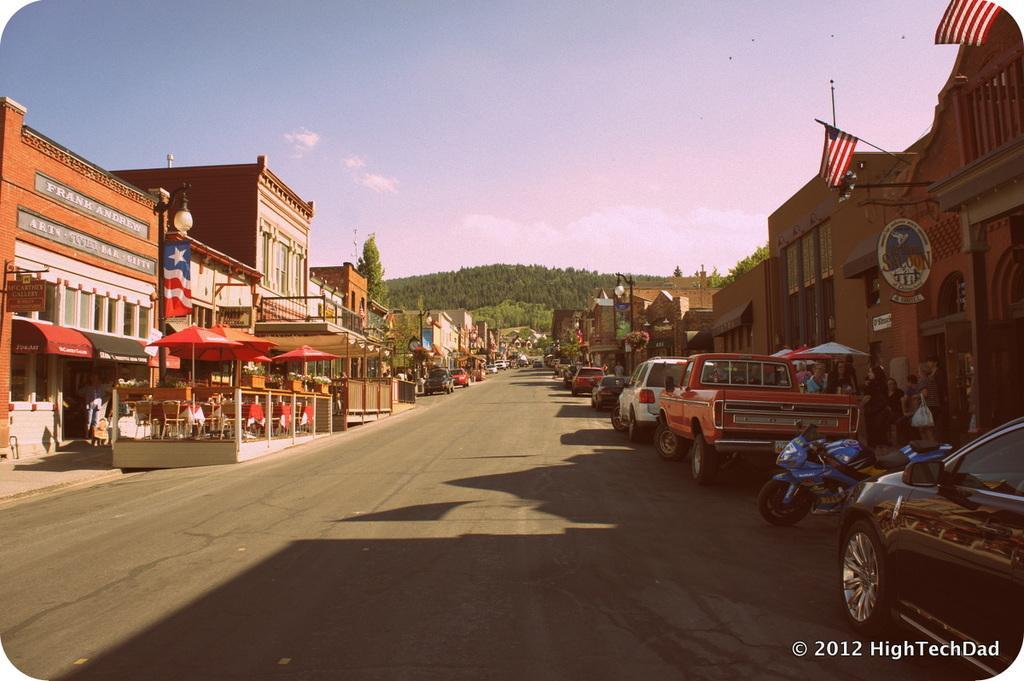Please provide a concise description of this image. In this image we can see buildings, street poles, street lights, parasols, chairs, tables, motor vehicles on the road, persons standing on the floor, trees and sky with clouds. 